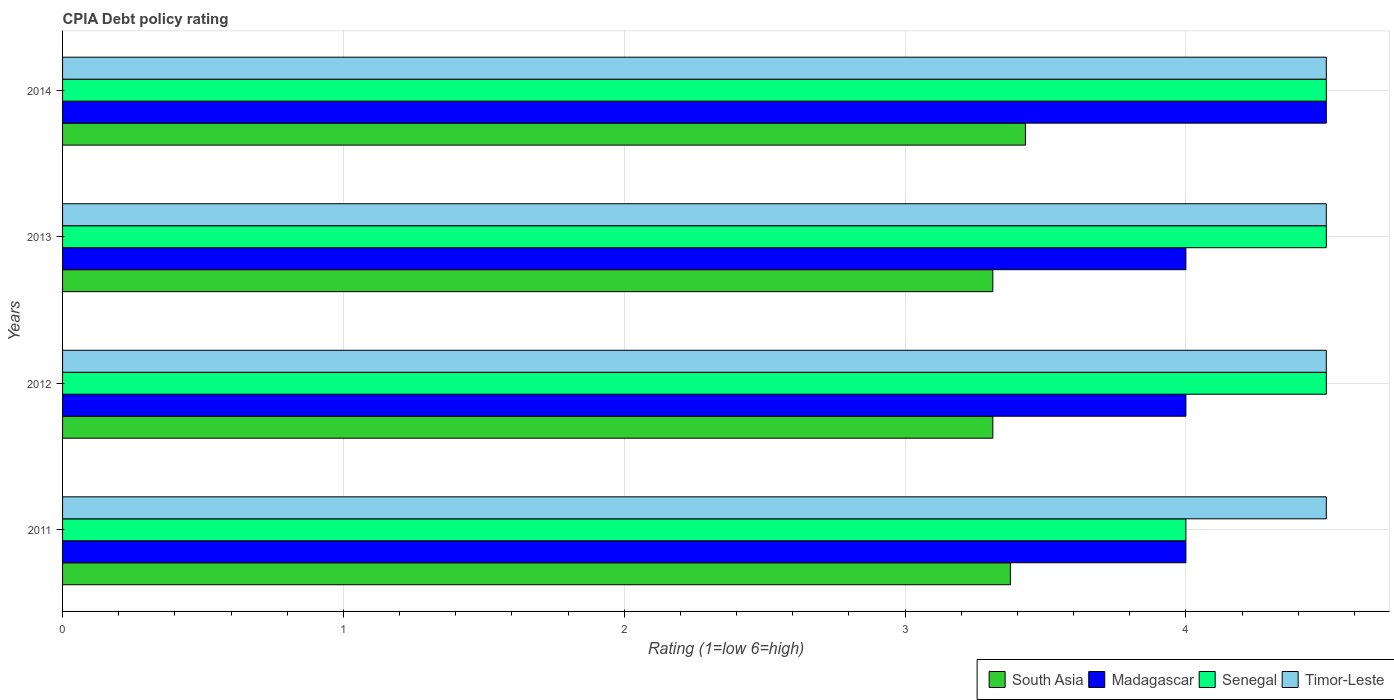Are the number of bars per tick equal to the number of legend labels?
Keep it short and to the point. Yes. Are the number of bars on each tick of the Y-axis equal?
Your answer should be compact. Yes. In how many cases, is the number of bars for a given year not equal to the number of legend labels?
Provide a succinct answer. 0. What is the CPIA rating in Timor-Leste in 2012?
Make the answer very short. 4.5. Across all years, what is the maximum CPIA rating in Madagascar?
Give a very brief answer. 4.5. Across all years, what is the minimum CPIA rating in South Asia?
Offer a very short reply. 3.31. What is the total CPIA rating in South Asia in the graph?
Provide a short and direct response. 13.43. What is the difference between the CPIA rating in South Asia in 2011 and the CPIA rating in Madagascar in 2014?
Give a very brief answer. -1.12. What is the average CPIA rating in Timor-Leste per year?
Your answer should be very brief. 4.5. Is the difference between the CPIA rating in Timor-Leste in 2012 and 2014 greater than the difference between the CPIA rating in Madagascar in 2012 and 2014?
Your answer should be compact. Yes. What is the difference between the highest and the lowest CPIA rating in South Asia?
Make the answer very short. 0.12. Is the sum of the CPIA rating in Timor-Leste in 2011 and 2013 greater than the maximum CPIA rating in Senegal across all years?
Provide a short and direct response. Yes. What does the 3rd bar from the top in 2011 represents?
Your response must be concise. Madagascar. What does the 1st bar from the bottom in 2013 represents?
Your response must be concise. South Asia. What is the difference between two consecutive major ticks on the X-axis?
Offer a terse response. 1. Are the values on the major ticks of X-axis written in scientific E-notation?
Make the answer very short. No. Does the graph contain grids?
Give a very brief answer. Yes. Where does the legend appear in the graph?
Your answer should be compact. Bottom right. What is the title of the graph?
Offer a very short reply. CPIA Debt policy rating. What is the label or title of the X-axis?
Provide a short and direct response. Rating (1=low 6=high). What is the label or title of the Y-axis?
Ensure brevity in your answer.  Years. What is the Rating (1=low 6=high) in South Asia in 2011?
Your answer should be compact. 3.38. What is the Rating (1=low 6=high) in South Asia in 2012?
Ensure brevity in your answer.  3.31. What is the Rating (1=low 6=high) of Madagascar in 2012?
Your answer should be very brief. 4. What is the Rating (1=low 6=high) of Timor-Leste in 2012?
Provide a short and direct response. 4.5. What is the Rating (1=low 6=high) of South Asia in 2013?
Provide a short and direct response. 3.31. What is the Rating (1=low 6=high) of South Asia in 2014?
Your answer should be very brief. 3.43. What is the Rating (1=low 6=high) of Madagascar in 2014?
Ensure brevity in your answer.  4.5. What is the Rating (1=low 6=high) in Senegal in 2014?
Ensure brevity in your answer.  4.5. What is the Rating (1=low 6=high) in Timor-Leste in 2014?
Give a very brief answer. 4.5. Across all years, what is the maximum Rating (1=low 6=high) of South Asia?
Your response must be concise. 3.43. Across all years, what is the maximum Rating (1=low 6=high) of Madagascar?
Ensure brevity in your answer.  4.5. Across all years, what is the maximum Rating (1=low 6=high) of Senegal?
Your response must be concise. 4.5. Across all years, what is the maximum Rating (1=low 6=high) in Timor-Leste?
Your answer should be very brief. 4.5. Across all years, what is the minimum Rating (1=low 6=high) of South Asia?
Make the answer very short. 3.31. Across all years, what is the minimum Rating (1=low 6=high) in Senegal?
Give a very brief answer. 4. What is the total Rating (1=low 6=high) of South Asia in the graph?
Provide a short and direct response. 13.43. What is the total Rating (1=low 6=high) in Madagascar in the graph?
Keep it short and to the point. 16.5. What is the total Rating (1=low 6=high) in Senegal in the graph?
Keep it short and to the point. 17.5. What is the total Rating (1=low 6=high) in Timor-Leste in the graph?
Offer a very short reply. 18. What is the difference between the Rating (1=low 6=high) in South Asia in 2011 and that in 2012?
Ensure brevity in your answer.  0.06. What is the difference between the Rating (1=low 6=high) of Madagascar in 2011 and that in 2012?
Offer a very short reply. 0. What is the difference between the Rating (1=low 6=high) in Timor-Leste in 2011 and that in 2012?
Make the answer very short. 0. What is the difference between the Rating (1=low 6=high) in South Asia in 2011 and that in 2013?
Your response must be concise. 0.06. What is the difference between the Rating (1=low 6=high) in Madagascar in 2011 and that in 2013?
Give a very brief answer. 0. What is the difference between the Rating (1=low 6=high) in Senegal in 2011 and that in 2013?
Keep it short and to the point. -0.5. What is the difference between the Rating (1=low 6=high) of South Asia in 2011 and that in 2014?
Provide a short and direct response. -0.05. What is the difference between the Rating (1=low 6=high) of Madagascar in 2011 and that in 2014?
Make the answer very short. -0.5. What is the difference between the Rating (1=low 6=high) in Senegal in 2011 and that in 2014?
Your response must be concise. -0.5. What is the difference between the Rating (1=low 6=high) of Timor-Leste in 2011 and that in 2014?
Provide a short and direct response. 0. What is the difference between the Rating (1=low 6=high) of South Asia in 2012 and that in 2013?
Keep it short and to the point. 0. What is the difference between the Rating (1=low 6=high) in Madagascar in 2012 and that in 2013?
Your answer should be very brief. 0. What is the difference between the Rating (1=low 6=high) of Senegal in 2012 and that in 2013?
Ensure brevity in your answer.  0. What is the difference between the Rating (1=low 6=high) of Timor-Leste in 2012 and that in 2013?
Offer a very short reply. 0. What is the difference between the Rating (1=low 6=high) in South Asia in 2012 and that in 2014?
Offer a terse response. -0.12. What is the difference between the Rating (1=low 6=high) in Madagascar in 2012 and that in 2014?
Provide a short and direct response. -0.5. What is the difference between the Rating (1=low 6=high) in Senegal in 2012 and that in 2014?
Offer a terse response. 0. What is the difference between the Rating (1=low 6=high) of South Asia in 2013 and that in 2014?
Make the answer very short. -0.12. What is the difference between the Rating (1=low 6=high) in Madagascar in 2013 and that in 2014?
Your answer should be compact. -0.5. What is the difference between the Rating (1=low 6=high) in Senegal in 2013 and that in 2014?
Provide a succinct answer. 0. What is the difference between the Rating (1=low 6=high) in South Asia in 2011 and the Rating (1=low 6=high) in Madagascar in 2012?
Ensure brevity in your answer.  -0.62. What is the difference between the Rating (1=low 6=high) of South Asia in 2011 and the Rating (1=low 6=high) of Senegal in 2012?
Your response must be concise. -1.12. What is the difference between the Rating (1=low 6=high) in South Asia in 2011 and the Rating (1=low 6=high) in Timor-Leste in 2012?
Offer a terse response. -1.12. What is the difference between the Rating (1=low 6=high) of Madagascar in 2011 and the Rating (1=low 6=high) of Senegal in 2012?
Give a very brief answer. -0.5. What is the difference between the Rating (1=low 6=high) in Senegal in 2011 and the Rating (1=low 6=high) in Timor-Leste in 2012?
Make the answer very short. -0.5. What is the difference between the Rating (1=low 6=high) of South Asia in 2011 and the Rating (1=low 6=high) of Madagascar in 2013?
Provide a short and direct response. -0.62. What is the difference between the Rating (1=low 6=high) of South Asia in 2011 and the Rating (1=low 6=high) of Senegal in 2013?
Offer a terse response. -1.12. What is the difference between the Rating (1=low 6=high) of South Asia in 2011 and the Rating (1=low 6=high) of Timor-Leste in 2013?
Provide a succinct answer. -1.12. What is the difference between the Rating (1=low 6=high) of Madagascar in 2011 and the Rating (1=low 6=high) of Senegal in 2013?
Your response must be concise. -0.5. What is the difference between the Rating (1=low 6=high) of Madagascar in 2011 and the Rating (1=low 6=high) of Timor-Leste in 2013?
Your response must be concise. -0.5. What is the difference between the Rating (1=low 6=high) of Senegal in 2011 and the Rating (1=low 6=high) of Timor-Leste in 2013?
Your answer should be very brief. -0.5. What is the difference between the Rating (1=low 6=high) in South Asia in 2011 and the Rating (1=low 6=high) in Madagascar in 2014?
Keep it short and to the point. -1.12. What is the difference between the Rating (1=low 6=high) of South Asia in 2011 and the Rating (1=low 6=high) of Senegal in 2014?
Provide a short and direct response. -1.12. What is the difference between the Rating (1=low 6=high) of South Asia in 2011 and the Rating (1=low 6=high) of Timor-Leste in 2014?
Ensure brevity in your answer.  -1.12. What is the difference between the Rating (1=low 6=high) in Madagascar in 2011 and the Rating (1=low 6=high) in Timor-Leste in 2014?
Your response must be concise. -0.5. What is the difference between the Rating (1=low 6=high) of South Asia in 2012 and the Rating (1=low 6=high) of Madagascar in 2013?
Ensure brevity in your answer.  -0.69. What is the difference between the Rating (1=low 6=high) in South Asia in 2012 and the Rating (1=low 6=high) in Senegal in 2013?
Offer a very short reply. -1.19. What is the difference between the Rating (1=low 6=high) in South Asia in 2012 and the Rating (1=low 6=high) in Timor-Leste in 2013?
Give a very brief answer. -1.19. What is the difference between the Rating (1=low 6=high) of Madagascar in 2012 and the Rating (1=low 6=high) of Timor-Leste in 2013?
Your response must be concise. -0.5. What is the difference between the Rating (1=low 6=high) in Senegal in 2012 and the Rating (1=low 6=high) in Timor-Leste in 2013?
Provide a succinct answer. 0. What is the difference between the Rating (1=low 6=high) in South Asia in 2012 and the Rating (1=low 6=high) in Madagascar in 2014?
Give a very brief answer. -1.19. What is the difference between the Rating (1=low 6=high) of South Asia in 2012 and the Rating (1=low 6=high) of Senegal in 2014?
Give a very brief answer. -1.19. What is the difference between the Rating (1=low 6=high) in South Asia in 2012 and the Rating (1=low 6=high) in Timor-Leste in 2014?
Give a very brief answer. -1.19. What is the difference between the Rating (1=low 6=high) in Madagascar in 2012 and the Rating (1=low 6=high) in Timor-Leste in 2014?
Offer a very short reply. -0.5. What is the difference between the Rating (1=low 6=high) of South Asia in 2013 and the Rating (1=low 6=high) of Madagascar in 2014?
Give a very brief answer. -1.19. What is the difference between the Rating (1=low 6=high) of South Asia in 2013 and the Rating (1=low 6=high) of Senegal in 2014?
Ensure brevity in your answer.  -1.19. What is the difference between the Rating (1=low 6=high) of South Asia in 2013 and the Rating (1=low 6=high) of Timor-Leste in 2014?
Ensure brevity in your answer.  -1.19. What is the difference between the Rating (1=low 6=high) in Madagascar in 2013 and the Rating (1=low 6=high) in Senegal in 2014?
Your response must be concise. -0.5. What is the difference between the Rating (1=low 6=high) of Madagascar in 2013 and the Rating (1=low 6=high) of Timor-Leste in 2014?
Your response must be concise. -0.5. What is the difference between the Rating (1=low 6=high) in Senegal in 2013 and the Rating (1=low 6=high) in Timor-Leste in 2014?
Your answer should be compact. 0. What is the average Rating (1=low 6=high) of South Asia per year?
Your answer should be very brief. 3.36. What is the average Rating (1=low 6=high) of Madagascar per year?
Your response must be concise. 4.12. What is the average Rating (1=low 6=high) of Senegal per year?
Give a very brief answer. 4.38. In the year 2011, what is the difference between the Rating (1=low 6=high) in South Asia and Rating (1=low 6=high) in Madagascar?
Offer a very short reply. -0.62. In the year 2011, what is the difference between the Rating (1=low 6=high) of South Asia and Rating (1=low 6=high) of Senegal?
Make the answer very short. -0.62. In the year 2011, what is the difference between the Rating (1=low 6=high) of South Asia and Rating (1=low 6=high) of Timor-Leste?
Offer a very short reply. -1.12. In the year 2011, what is the difference between the Rating (1=low 6=high) of Senegal and Rating (1=low 6=high) of Timor-Leste?
Your answer should be compact. -0.5. In the year 2012, what is the difference between the Rating (1=low 6=high) in South Asia and Rating (1=low 6=high) in Madagascar?
Offer a terse response. -0.69. In the year 2012, what is the difference between the Rating (1=low 6=high) in South Asia and Rating (1=low 6=high) in Senegal?
Your answer should be very brief. -1.19. In the year 2012, what is the difference between the Rating (1=low 6=high) in South Asia and Rating (1=low 6=high) in Timor-Leste?
Give a very brief answer. -1.19. In the year 2012, what is the difference between the Rating (1=low 6=high) in Madagascar and Rating (1=low 6=high) in Senegal?
Give a very brief answer. -0.5. In the year 2012, what is the difference between the Rating (1=low 6=high) of Madagascar and Rating (1=low 6=high) of Timor-Leste?
Ensure brevity in your answer.  -0.5. In the year 2013, what is the difference between the Rating (1=low 6=high) of South Asia and Rating (1=low 6=high) of Madagascar?
Ensure brevity in your answer.  -0.69. In the year 2013, what is the difference between the Rating (1=low 6=high) in South Asia and Rating (1=low 6=high) in Senegal?
Your answer should be very brief. -1.19. In the year 2013, what is the difference between the Rating (1=low 6=high) of South Asia and Rating (1=low 6=high) of Timor-Leste?
Your response must be concise. -1.19. In the year 2013, what is the difference between the Rating (1=low 6=high) of Madagascar and Rating (1=low 6=high) of Senegal?
Provide a short and direct response. -0.5. In the year 2013, what is the difference between the Rating (1=low 6=high) of Senegal and Rating (1=low 6=high) of Timor-Leste?
Your answer should be compact. 0. In the year 2014, what is the difference between the Rating (1=low 6=high) in South Asia and Rating (1=low 6=high) in Madagascar?
Keep it short and to the point. -1.07. In the year 2014, what is the difference between the Rating (1=low 6=high) of South Asia and Rating (1=low 6=high) of Senegal?
Your response must be concise. -1.07. In the year 2014, what is the difference between the Rating (1=low 6=high) of South Asia and Rating (1=low 6=high) of Timor-Leste?
Your answer should be very brief. -1.07. In the year 2014, what is the difference between the Rating (1=low 6=high) in Madagascar and Rating (1=low 6=high) in Timor-Leste?
Ensure brevity in your answer.  0. In the year 2014, what is the difference between the Rating (1=low 6=high) in Senegal and Rating (1=low 6=high) in Timor-Leste?
Provide a short and direct response. 0. What is the ratio of the Rating (1=low 6=high) in South Asia in 2011 to that in 2012?
Ensure brevity in your answer.  1.02. What is the ratio of the Rating (1=low 6=high) in South Asia in 2011 to that in 2013?
Your answer should be very brief. 1.02. What is the ratio of the Rating (1=low 6=high) of Timor-Leste in 2011 to that in 2013?
Offer a very short reply. 1. What is the ratio of the Rating (1=low 6=high) in South Asia in 2011 to that in 2014?
Your answer should be compact. 0.98. What is the ratio of the Rating (1=low 6=high) of Madagascar in 2011 to that in 2014?
Offer a very short reply. 0.89. What is the ratio of the Rating (1=low 6=high) of Senegal in 2011 to that in 2014?
Your response must be concise. 0.89. What is the ratio of the Rating (1=low 6=high) in South Asia in 2012 to that in 2013?
Make the answer very short. 1. What is the ratio of the Rating (1=low 6=high) of Madagascar in 2012 to that in 2013?
Provide a short and direct response. 1. What is the ratio of the Rating (1=low 6=high) in Timor-Leste in 2012 to that in 2013?
Provide a succinct answer. 1. What is the ratio of the Rating (1=low 6=high) of South Asia in 2012 to that in 2014?
Offer a terse response. 0.97. What is the ratio of the Rating (1=low 6=high) of Madagascar in 2012 to that in 2014?
Provide a short and direct response. 0.89. What is the ratio of the Rating (1=low 6=high) in Timor-Leste in 2012 to that in 2014?
Offer a very short reply. 1. What is the ratio of the Rating (1=low 6=high) in South Asia in 2013 to that in 2014?
Provide a short and direct response. 0.97. What is the ratio of the Rating (1=low 6=high) in Senegal in 2013 to that in 2014?
Offer a very short reply. 1. What is the difference between the highest and the second highest Rating (1=low 6=high) of South Asia?
Offer a terse response. 0.05. What is the difference between the highest and the second highest Rating (1=low 6=high) of Senegal?
Your answer should be compact. 0. What is the difference between the highest and the lowest Rating (1=low 6=high) in South Asia?
Ensure brevity in your answer.  0.12. What is the difference between the highest and the lowest Rating (1=low 6=high) in Madagascar?
Provide a succinct answer. 0.5. What is the difference between the highest and the lowest Rating (1=low 6=high) in Senegal?
Your response must be concise. 0.5. 